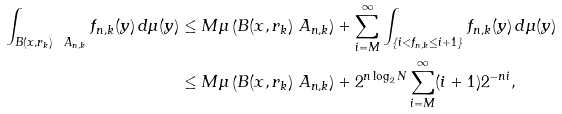Convert formula to latex. <formula><loc_0><loc_0><loc_500><loc_500>\int _ { B ( x , r _ { k } ) \ A _ { n , k } } f _ { n , k } ( y ) \, d \mu ( y ) & \leq M \mu \left ( B ( x , r _ { k } ) \ A _ { n , k } \right ) + \sum _ { i = M } ^ { \infty } \int _ { \{ i < f _ { n , k } \leq i + 1 \} } f _ { n , k } ( y ) \, d \mu ( y ) \\ & \leq M \mu \left ( B ( x , r _ { k } ) \ A _ { n , k } \right ) + 2 ^ { n \log _ { 2 } N } \sum _ { i = M } ^ { \infty } ( i + 1 ) 2 ^ { - n i } ,</formula> 